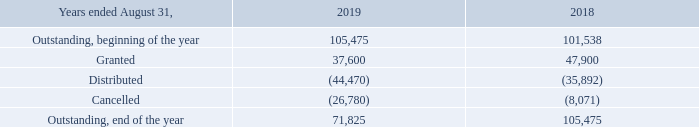ISU plan
The Corporation offers to its executive officers and designated employees an Incentive Share Unit ("ISU") Plan. According to this plan, executive
officers and designated employees periodically receive a given number of ISUs which entitle the participants to receive subordinate voting shares of the Corporation after three years less one day from the date of grant.
The number of ISUs is based on the dollar value of the award and the average closing stock price of the Corporation for the previous twelve month period ending August 31. A trust was created for the purpose of purchasing these shares on the stock market in order to protect against stock price fluctuation and the Corporation instructed the trustee to purchase subordinate voting shares of the Corporation on the stock market. These shares are purchased and are held in trust for the participants until they are fully vested.
The trust, considered as a special purpose entity, is consolidated in the Corporation’s financial statements with the value of the acquired subordinate voting shares held in trust under the ISU Plan presented in reduction of share capital.
Under the ISU Plan, the following ISUs were granted by the Corporation and are outstanding at August 31:
A compensation expense of $2,046,000 ($2,461,000 in 2018) was recorded for the year ended August 31, 2019 related to this plan.
How is  the number of ISUs determined? The number of isus is based on the dollar value of the award and the average closing stock price of the corporation for the previous twelve month period ending august 31. What was the compensation expense in August 2019? $2,046,000. What was the granted ISUs in 2019? 37,600. What was the increase / (decrease) in the Outstanding, beginning of the year from 2018 to 2019? 105,475 - 101,538
Answer: 3937. What was the average granted from 2018 to 2019? (37,600 + 47,900) / 2
Answer: 42750. What was the average distributed from 2018 to 2019? -(44,470 + 35,892) / 2
Answer: -40181. 